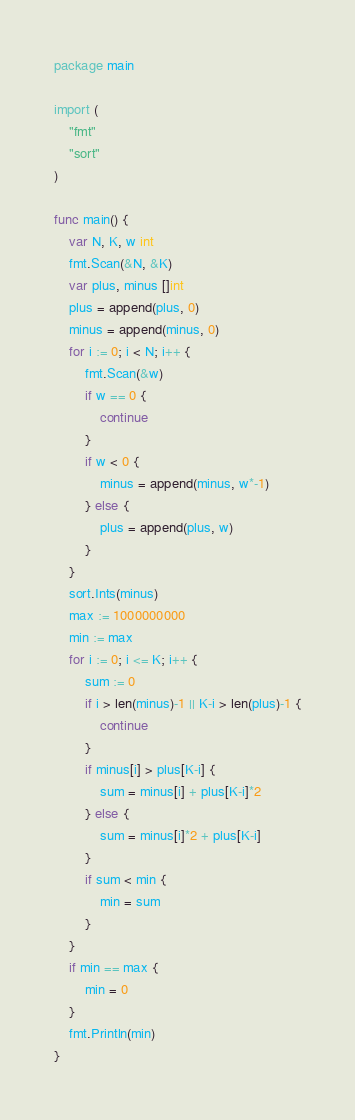<code> <loc_0><loc_0><loc_500><loc_500><_Go_>package main

import (
	"fmt"
	"sort"
)

func main() {
	var N, K, w int
	fmt.Scan(&N, &K)
	var plus, minus []int
	plus = append(plus, 0)
	minus = append(minus, 0)
	for i := 0; i < N; i++ {
		fmt.Scan(&w)
		if w == 0 {
			continue
		}
		if w < 0 {
			minus = append(minus, w*-1)
		} else {
			plus = append(plus, w)
		}
	}
	sort.Ints(minus)
	max := 1000000000
	min := max
	for i := 0; i <= K; i++ {
		sum := 0
		if i > len(minus)-1 || K-i > len(plus)-1 {
			continue
		}
		if minus[i] > plus[K-i] {
			sum = minus[i] + plus[K-i]*2
		} else {
			sum = minus[i]*2 + plus[K-i]
		}
		if sum < min {
			min = sum
		}
	}
	if min == max {
		min = 0
	}
	fmt.Println(min)
}</code> 